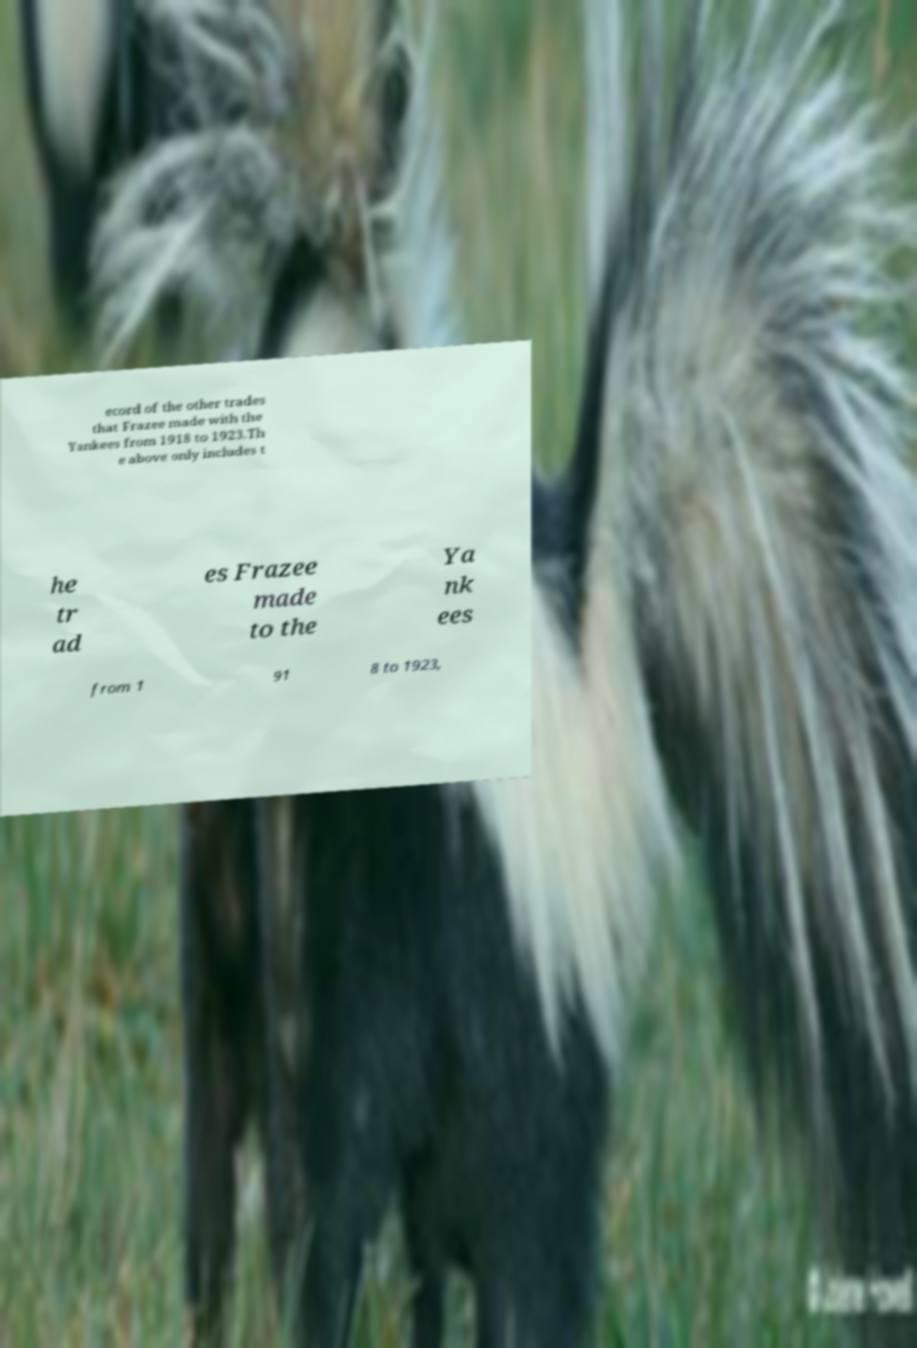For documentation purposes, I need the text within this image transcribed. Could you provide that? ecord of the other trades that Frazee made with the Yankees from 1918 to 1923.Th e above only includes t he tr ad es Frazee made to the Ya nk ees from 1 91 8 to 1923, 